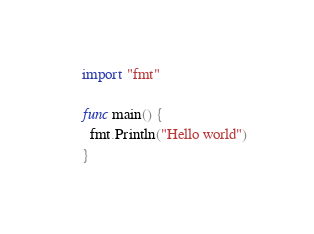Convert code to text. <code><loc_0><loc_0><loc_500><loc_500><_Go_>import "fmt"

func main() {
  fmt.Println("Hello world")
}
</code> 